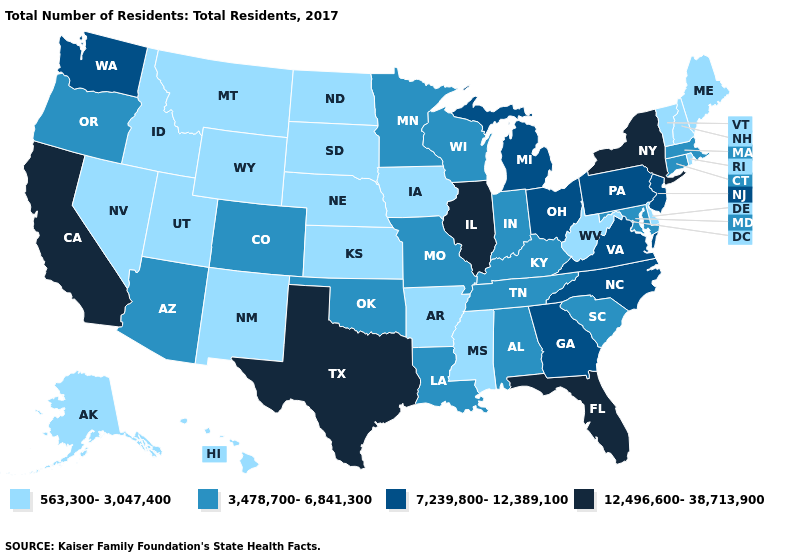What is the value of Minnesota?
Short answer required. 3,478,700-6,841,300. Does the map have missing data?
Quick response, please. No. Name the states that have a value in the range 7,239,800-12,389,100?
Quick response, please. Georgia, Michigan, New Jersey, North Carolina, Ohio, Pennsylvania, Virginia, Washington. What is the value of Rhode Island?
Answer briefly. 563,300-3,047,400. What is the value of Maryland?
Be succinct. 3,478,700-6,841,300. Among the states that border Oregon , does Washington have the highest value?
Write a very short answer. No. Name the states that have a value in the range 12,496,600-38,713,900?
Quick response, please. California, Florida, Illinois, New York, Texas. How many symbols are there in the legend?
Be succinct. 4. Name the states that have a value in the range 7,239,800-12,389,100?
Be succinct. Georgia, Michigan, New Jersey, North Carolina, Ohio, Pennsylvania, Virginia, Washington. Does Wisconsin have the same value as Kentucky?
Concise answer only. Yes. What is the value of Kentucky?
Short answer required. 3,478,700-6,841,300. What is the value of Iowa?
Keep it brief. 563,300-3,047,400. What is the highest value in the USA?
Be succinct. 12,496,600-38,713,900. 